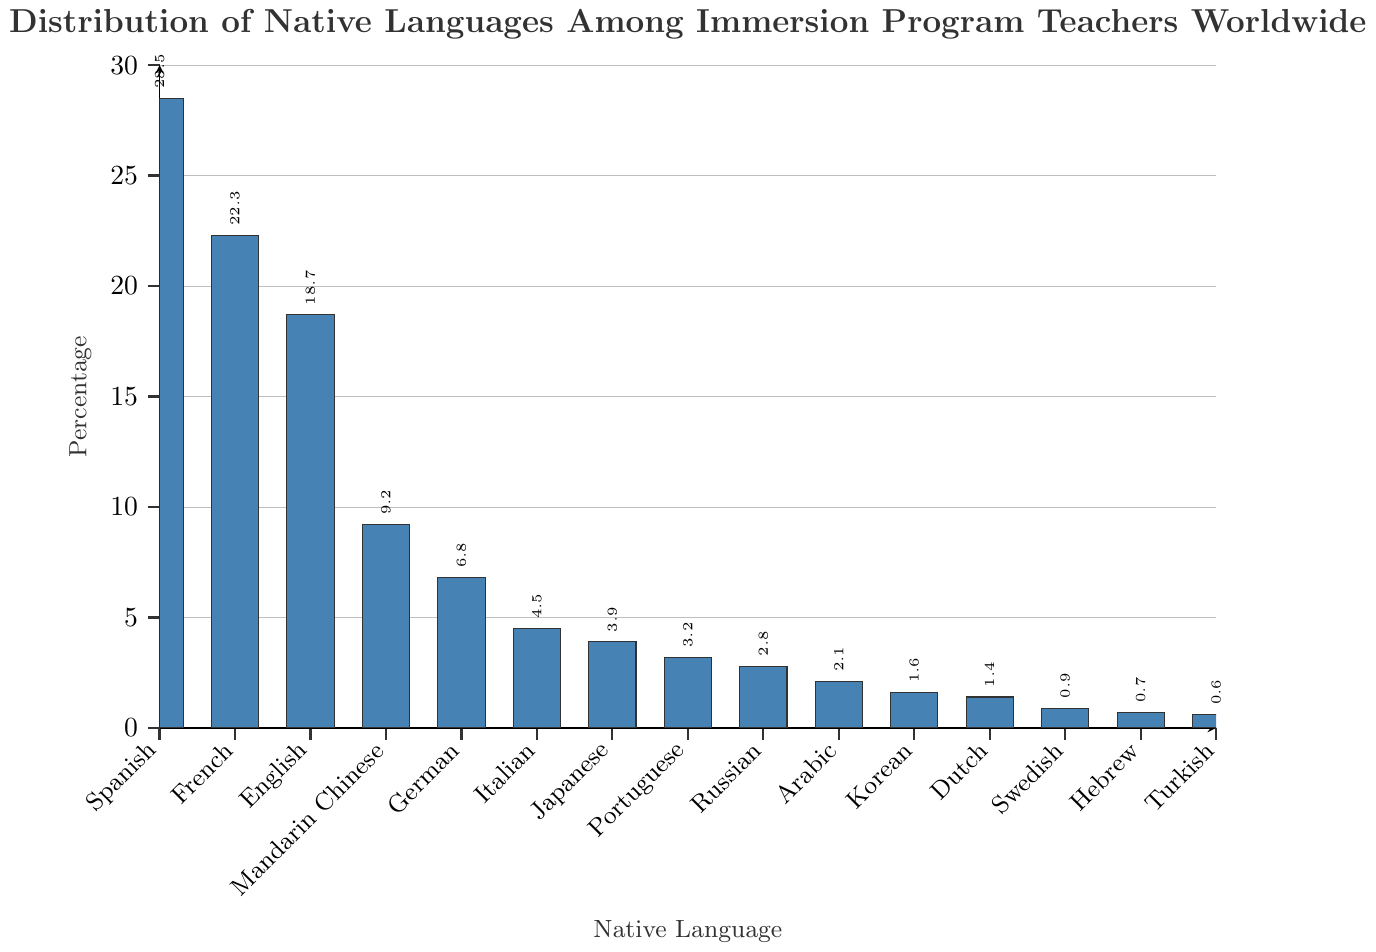What percentage of immersion program teachers have Spanish as their native language? The bar corresponding to Spanish shows a height representing 28.5 percent.
Answer: 28.5% Which two languages have the closest percentage of native speakers among immersion program teachers? Observing the heights of the bars, we see that Dutch and Swedish have very close percentages of 1.4% and 0.9%, respectively.
Answer: Dutch and Swedish How many languages have a percentage of native speakers greater than 10%? By inspecting the heights of the bars, we see that Spanish, French, and English each have percentages greater than 10%.
Answer: 3 What is the combined percentage of teachers with Mandarin Chinese, German, and Italian as their native languages? Add the percentages for Mandarin Chinese (9.2%), German (6.8%), and Italian (4.5%): 9.2 + 6.8 + 4.5 = 20.5%.
Answer: 20.5% Which language has the second highest percentage of native speakers? The bar corresponding to French is the second highest, indicating 22.3%.
Answer: French What is the difference in percentage between teachers with English as their native language and those with Portuguese as their native language? Subtract the percentage for Portuguese (3.2%) from that for English (18.7%): 18.7 - 3.2 = 15.5%.
Answer: 15.5% Which language has the lowest percentage of native speakers among immersion program teachers? The shortest bar belongs to Turkish, indicating the lowest percentage of 0.6%.
Answer: Turkish How many languages have a percentage of less than 5%? By observing the lengths of the bars, we find that Italian, Japanese, Portuguese, Russian, Arabic, Korean, Dutch, Swedish, Hebrew, and Turkish each have percentages less than 5%.
Answer: 10 Is the percentage of teachers with Japanese as their native language greater than or less than the percentage of teachers with Portuguese as their native language? The bar for Japanese (3.9%) is taller than the bar for Portuguese (3.2%).
Answer: Greater What is the average percentage of teachers having Arabic, Korean, Dutch, Swedish, Hebrew, and Turkish as their native languages? Calculate the sum of the percentages for Arabic (2.1%), Korean (1.6%), Dutch (1.4%), Swedish (0.9%), Hebrew (0.7%), and Turkish (0.6%), and then divide by 6: (2.1 + 1.6 + 1.4 + 0.9 + 0.7 + 0.6) / 6 = 7.3 / 6 ≈ 1.22%.
Answer: 1.22% 